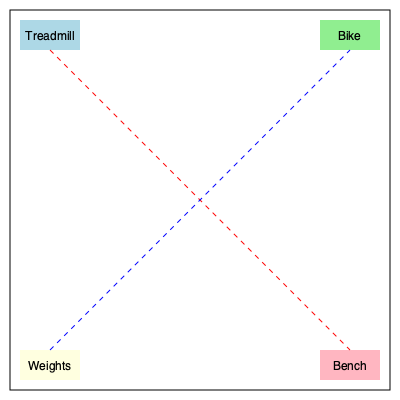In this gym layout, what is the approximate ratio of the distance between the treadmill and the bench to the distance between the weights and the bike? To solve this problem, let's follow these steps:

1. Observe that the gym layout forms a square, and the equipment is placed at the corners.

2. The distance between the treadmill and the bench forms one diagonal of the square, while the distance between the weights and the bike forms the other diagonal.

3. In a square, both diagonals are equal in length. We can prove this using the Pythagorean theorem:
   Let the side length of the square be $a$. Then each diagonal $d$ is:
   $d = \sqrt{a^2 + a^2} = \sqrt{2a^2} = a\sqrt{2}$

4. Since both diagonals are equal, the ratio of their lengths is:

   $$\frac{\text{Distance(Treadmill to Bench)}}{\text{Distance(Weights to Bike)}} = \frac{a\sqrt{2}}{a\sqrt{2}} = 1$$

5. Therefore, the ratio of the two distances is 1:1 or simply 1.
Answer: 1 